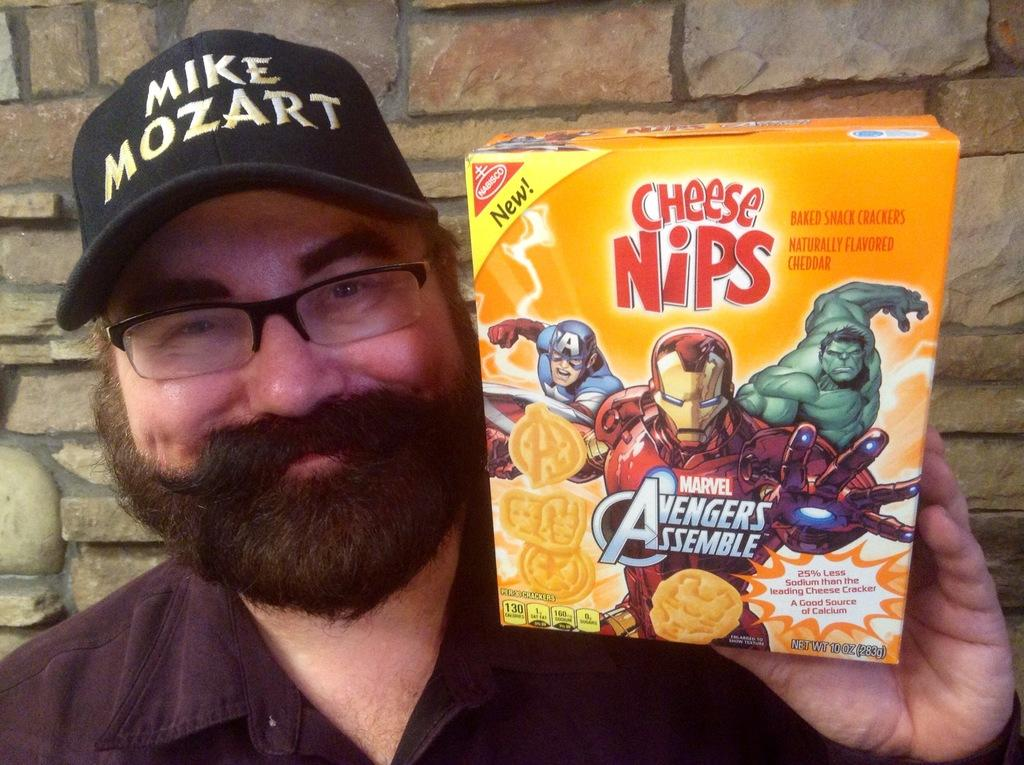Who is present in the image? There is a man in the image. What is the man wearing on his face? The man is wearing spectacles. What is the man wearing on his head? The man is wearing a cap. What is the man holding in his hand? The man is holding a box. What is the man's facial expression? The man is smiling. What can be seen in the background of the image? There is a wall in the background of the image. What type of flesh can be seen in the image? There is no flesh visible in the image; it features a man wearing spectacles, a cap, and holding a box. What song is the man singing in the image? There is no indication in the image that the man is singing a song. 